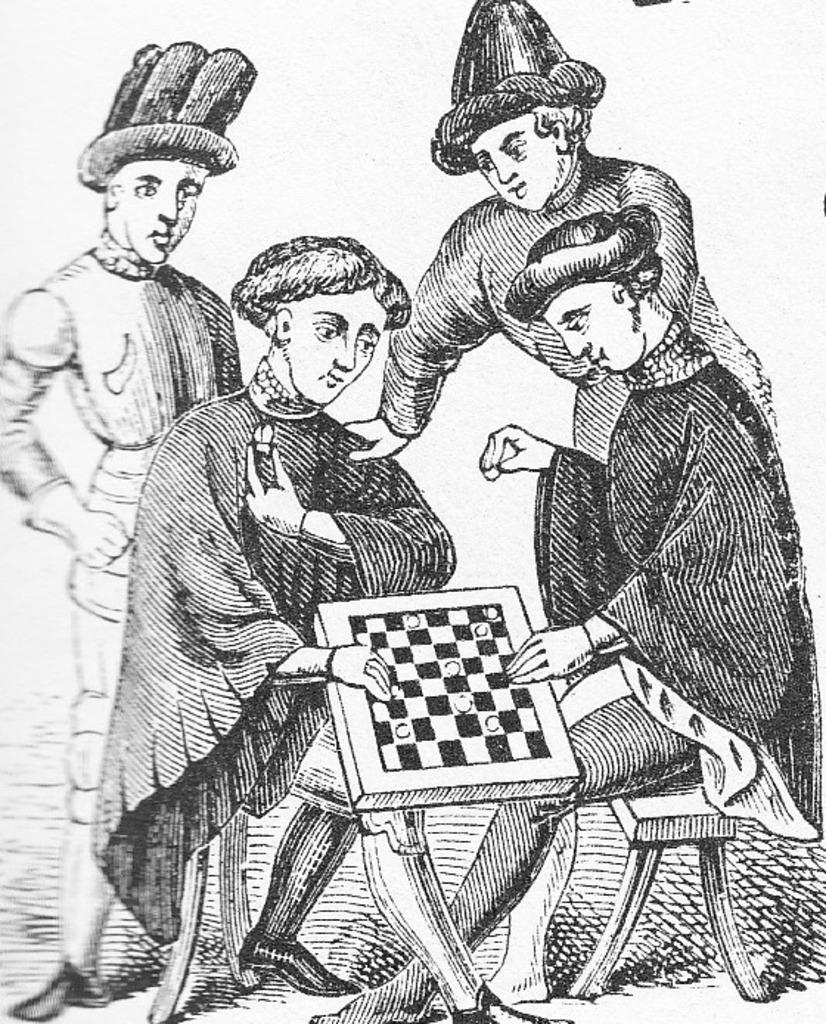What is the main subject of the image? There is a painting in the image. Can you describe the people in the image? Two men are sitting and two men are standing in the image. What object is located in the middle of the image? There is a chess board in the middle of the image. What is the aftermath of the protest in the image? There is no protest or aftermath present in the image; it features a painting with people and a chess board. How many bits can be seen in the image? There are no bits present in the image. 